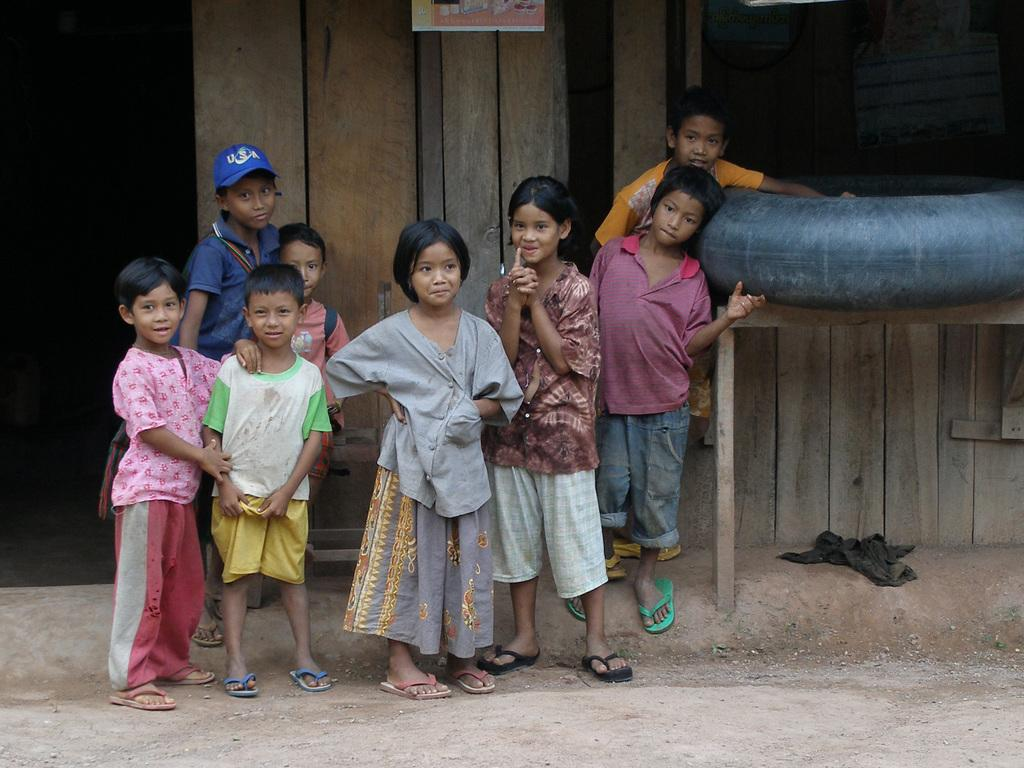What are the children doing in the image? The children are standing on the ground in the image. What can be seen on the right side of the image? There is a table on the right side of the image. What is on the table? There is an object on the table in the image. What is visible in the background of the image? There is a wooden wall in the background of the image. What type of leather is being used to make the bread in the image? There is no bread or leather present in the image. 